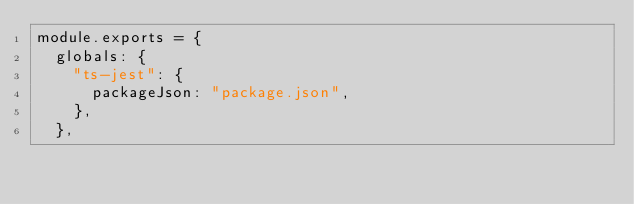Convert code to text. <code><loc_0><loc_0><loc_500><loc_500><_JavaScript_>module.exports = {
  globals: {
    "ts-jest": {
      packageJson: "package.json",
    },
  },</code> 